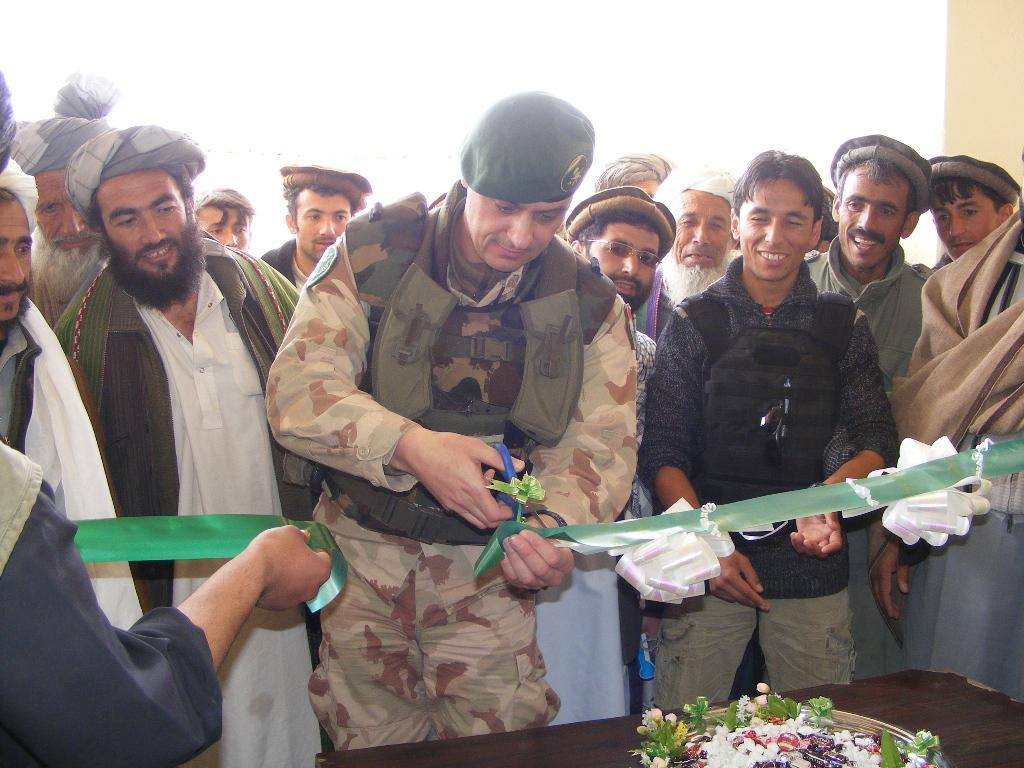How many people are in the group that is visible in the image? There is a group of people standing in the image, but the exact number cannot be determined from the provided facts. What is the person holding in the image? The person is holding a ribbon and scissors in the image. What can be seen on the table in the image? There is a tray with flowers on a table in the image. Can you tell me how many snakes are slithering around the feet of the people in the image? There are no snakes visible in the image; it only shows a group of people, a person holding a ribbon and scissors, and a tray with flowers on a table. 